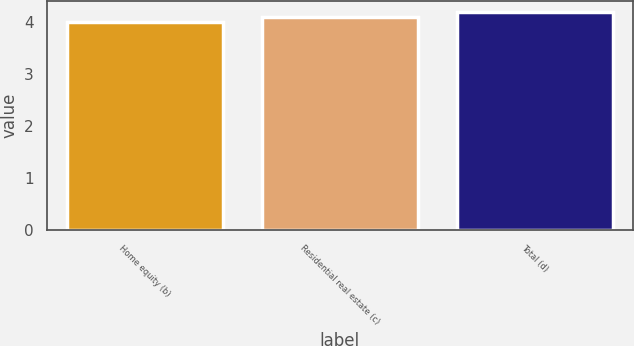Convert chart. <chart><loc_0><loc_0><loc_500><loc_500><bar_chart><fcel>Home equity (b)<fcel>Residential real estate (c)<fcel>Total (d)<nl><fcel>4<fcel>4.1<fcel>4.2<nl></chart> 